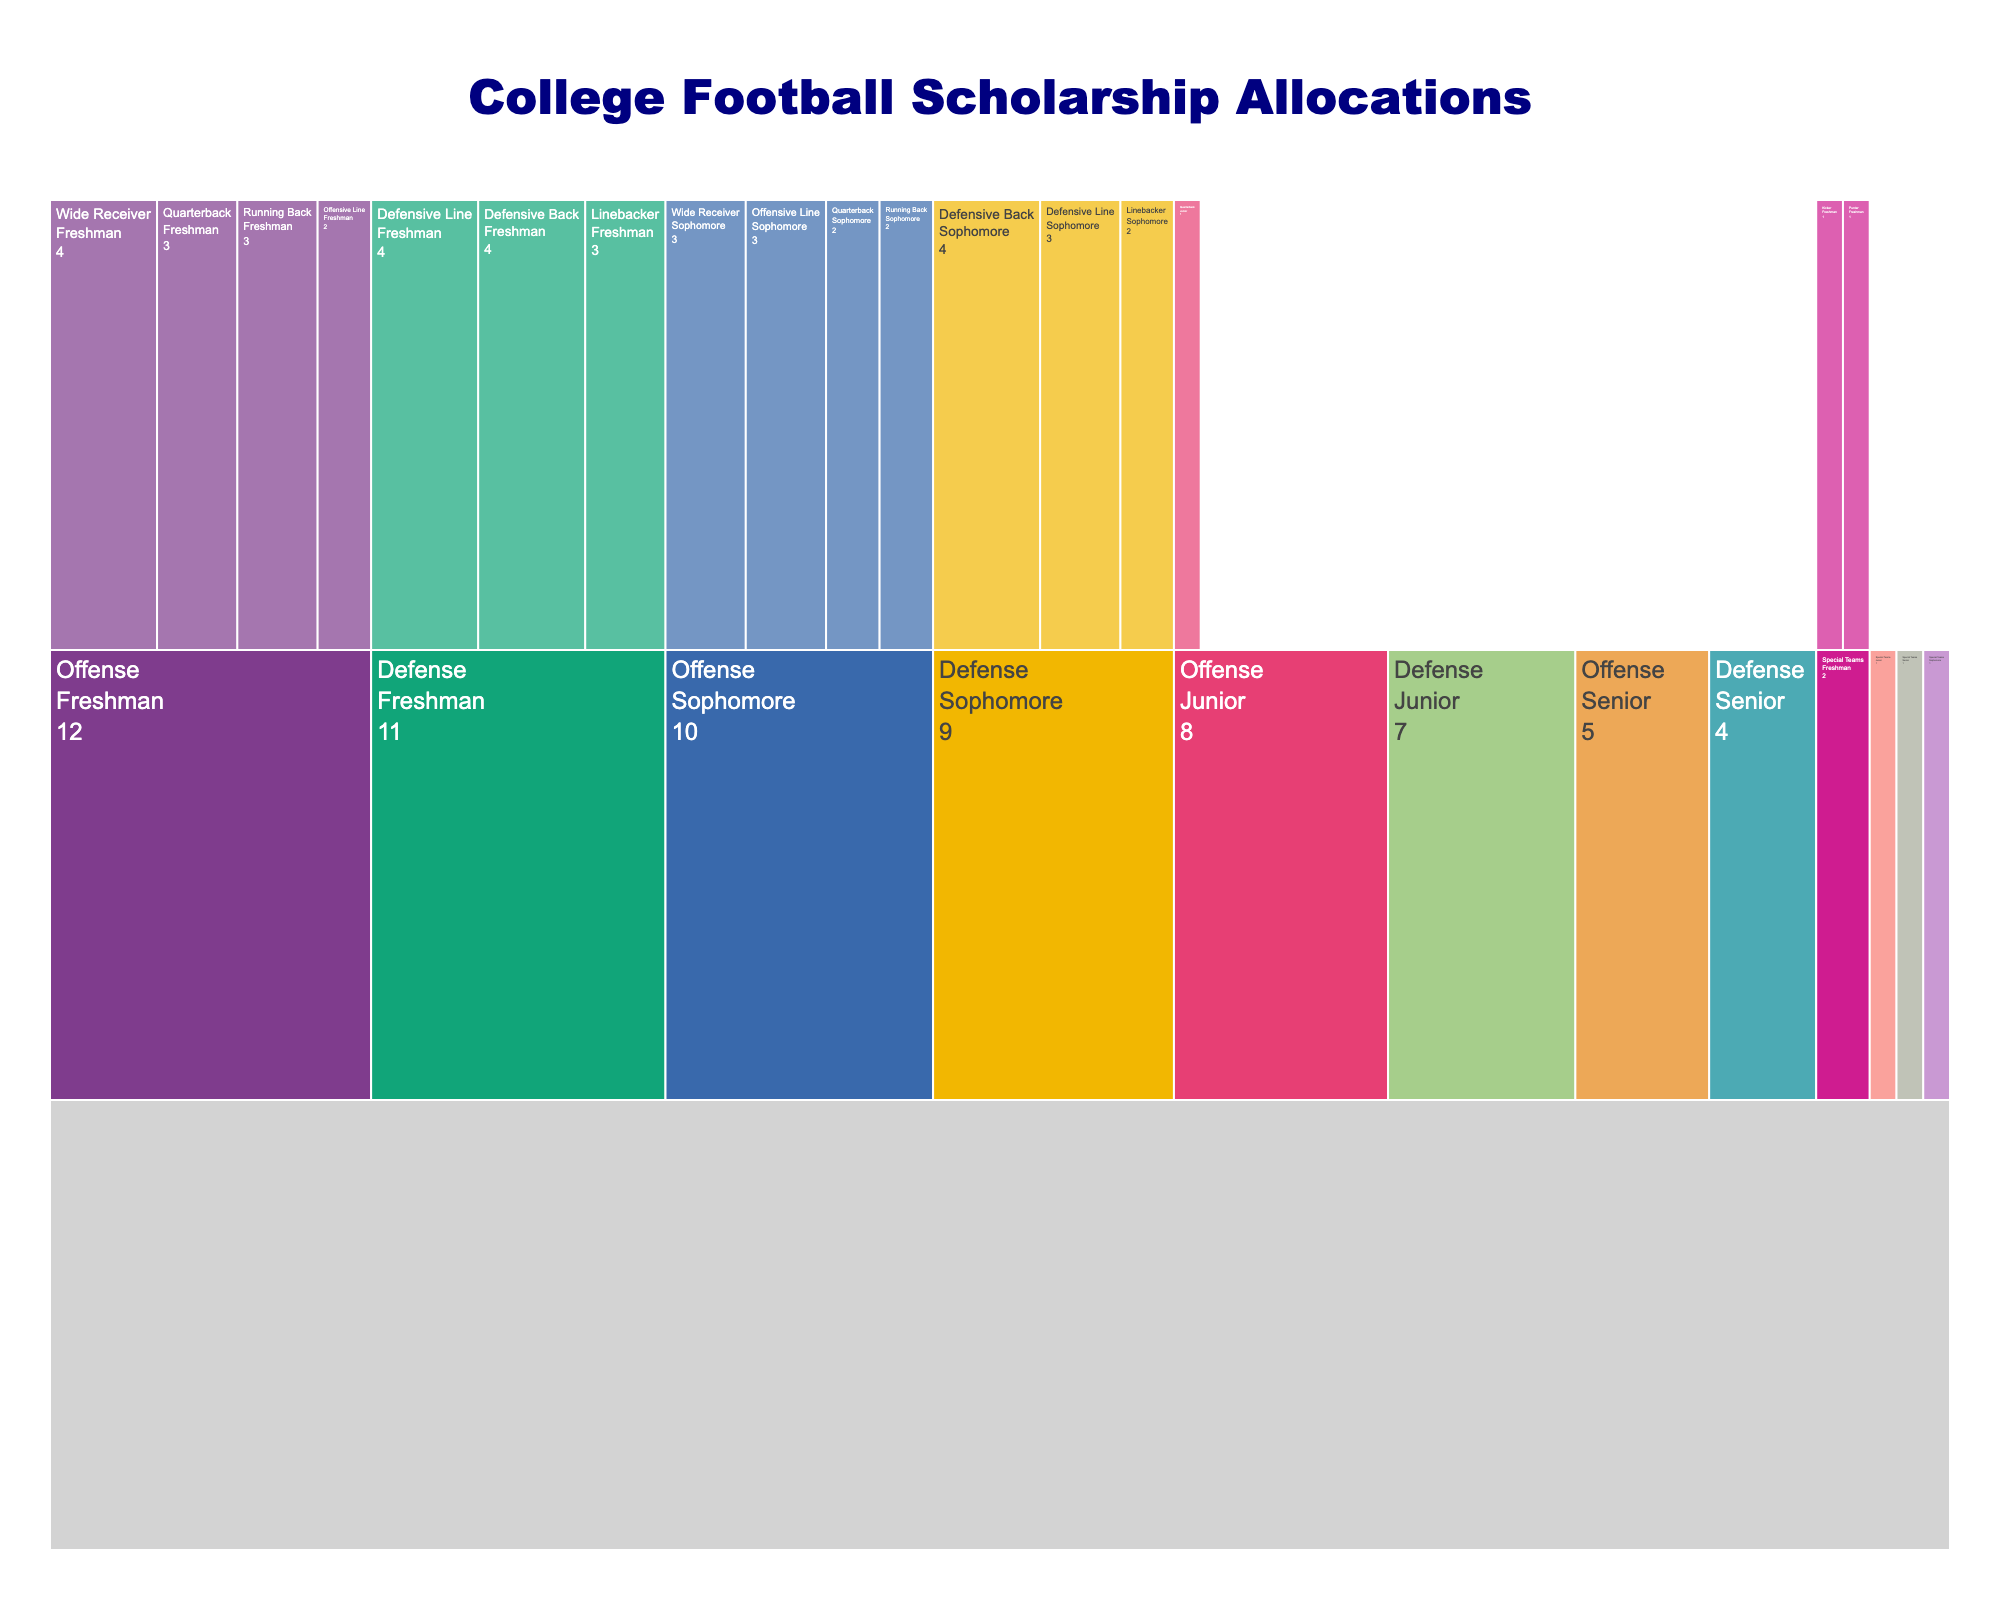What is the total allocation for Freshman players on Offense? To find the total allocation for Freshman players on Offense, sum the allocations for the specific positions under Freshman in Offense. The positions are Quarterback (3), Running Back (3), Wide Receiver (4), and Offensive Line (2). So, 3 + 3 + 4 + 2 = 12.
Answer: 12 What position on Defense has the highest allocation among Sophomore players? Look at the allocations for Defensive positions among Sophomores. The positions and their allocations are Defensive Line (3), Linebacker (2), and Defensive Back (4). Therefore, the Defensive Back has the highest allocation.
Answer: Defensive Back How does the total allocation for Senior players compare between Offense and Defense? Sum up the allocations for Senior players under Offense and Defense. For Offense: Senior has Quarterback (0, implied), Running Back (0, implied), Wide Receiver (0, implied), and Offensive Line (5) - so a total of 5. For Defense: Senior has Defensive Line (2, implied), Linebacker (0, implied), and Defensive Back (2) - so a total of 4. Comparing 5 (Offense total) against 4 (Defense total) shows Offense has more.
Answer: Offense has more Which Special Teams position has the least allocation as Freshman? Within the Special Teams Freshman category, the positions are Kicker (1) and Punter (1). Both have the same allocation, so none is less than the other.
Answer: Both have the least What is the total allocation for Junior players across all positions? Add up all Junior allocations for every position. Junior (Offense 8, Defense 7, Special Teams 1): 8 + 7 + 1 = 16.
Answer: 16 Which Offensive position receives the most scholarships among Freshman players? Check the allocations under Freshman in the Offense positions. The allocations are Quarterback (3), Running Back (3), Wide Receiver (4), and Offensive Line (2). The Wide Receiver has the highest allocation.
Answer: Wide Receiver Out of all Freshman players, which category has the highest allocation? Compare the Freshman allocations across Offense, Defense, and Special Teams. Offense Freshman (12), Defense Freshman (11), Special Teams Freshman (2). The highest is the Offense Freshman.
Answer: Offense What is the sum of the allocations for Sophomores in all categories? Add the Sophomore allocations for all positions. Offense Sophomore (10), Defense Sophomore (9), Special Teams Sophomore (1): 10 + 9 + 1 = 20.
Answer: 20 